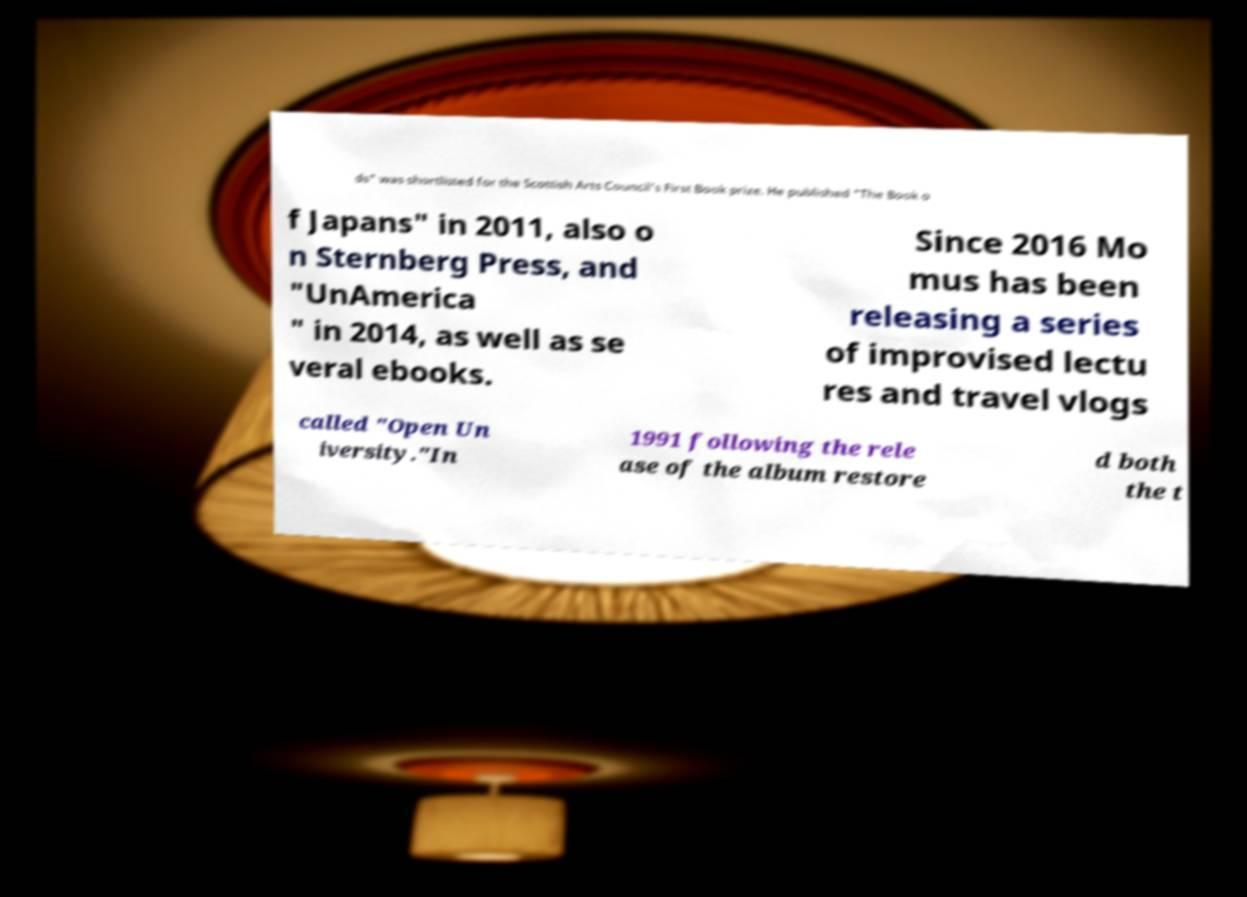What messages or text are displayed in this image? I need them in a readable, typed format. ds" was shortlisted for the Scottish Arts Council's First Book prize. He published "The Book o f Japans" in 2011, also o n Sternberg Press, and "UnAmerica " in 2014, as well as se veral ebooks. Since 2016 Mo mus has been releasing a series of improvised lectu res and travel vlogs called "Open Un iversity."In 1991 following the rele ase of the album restore d both the t 